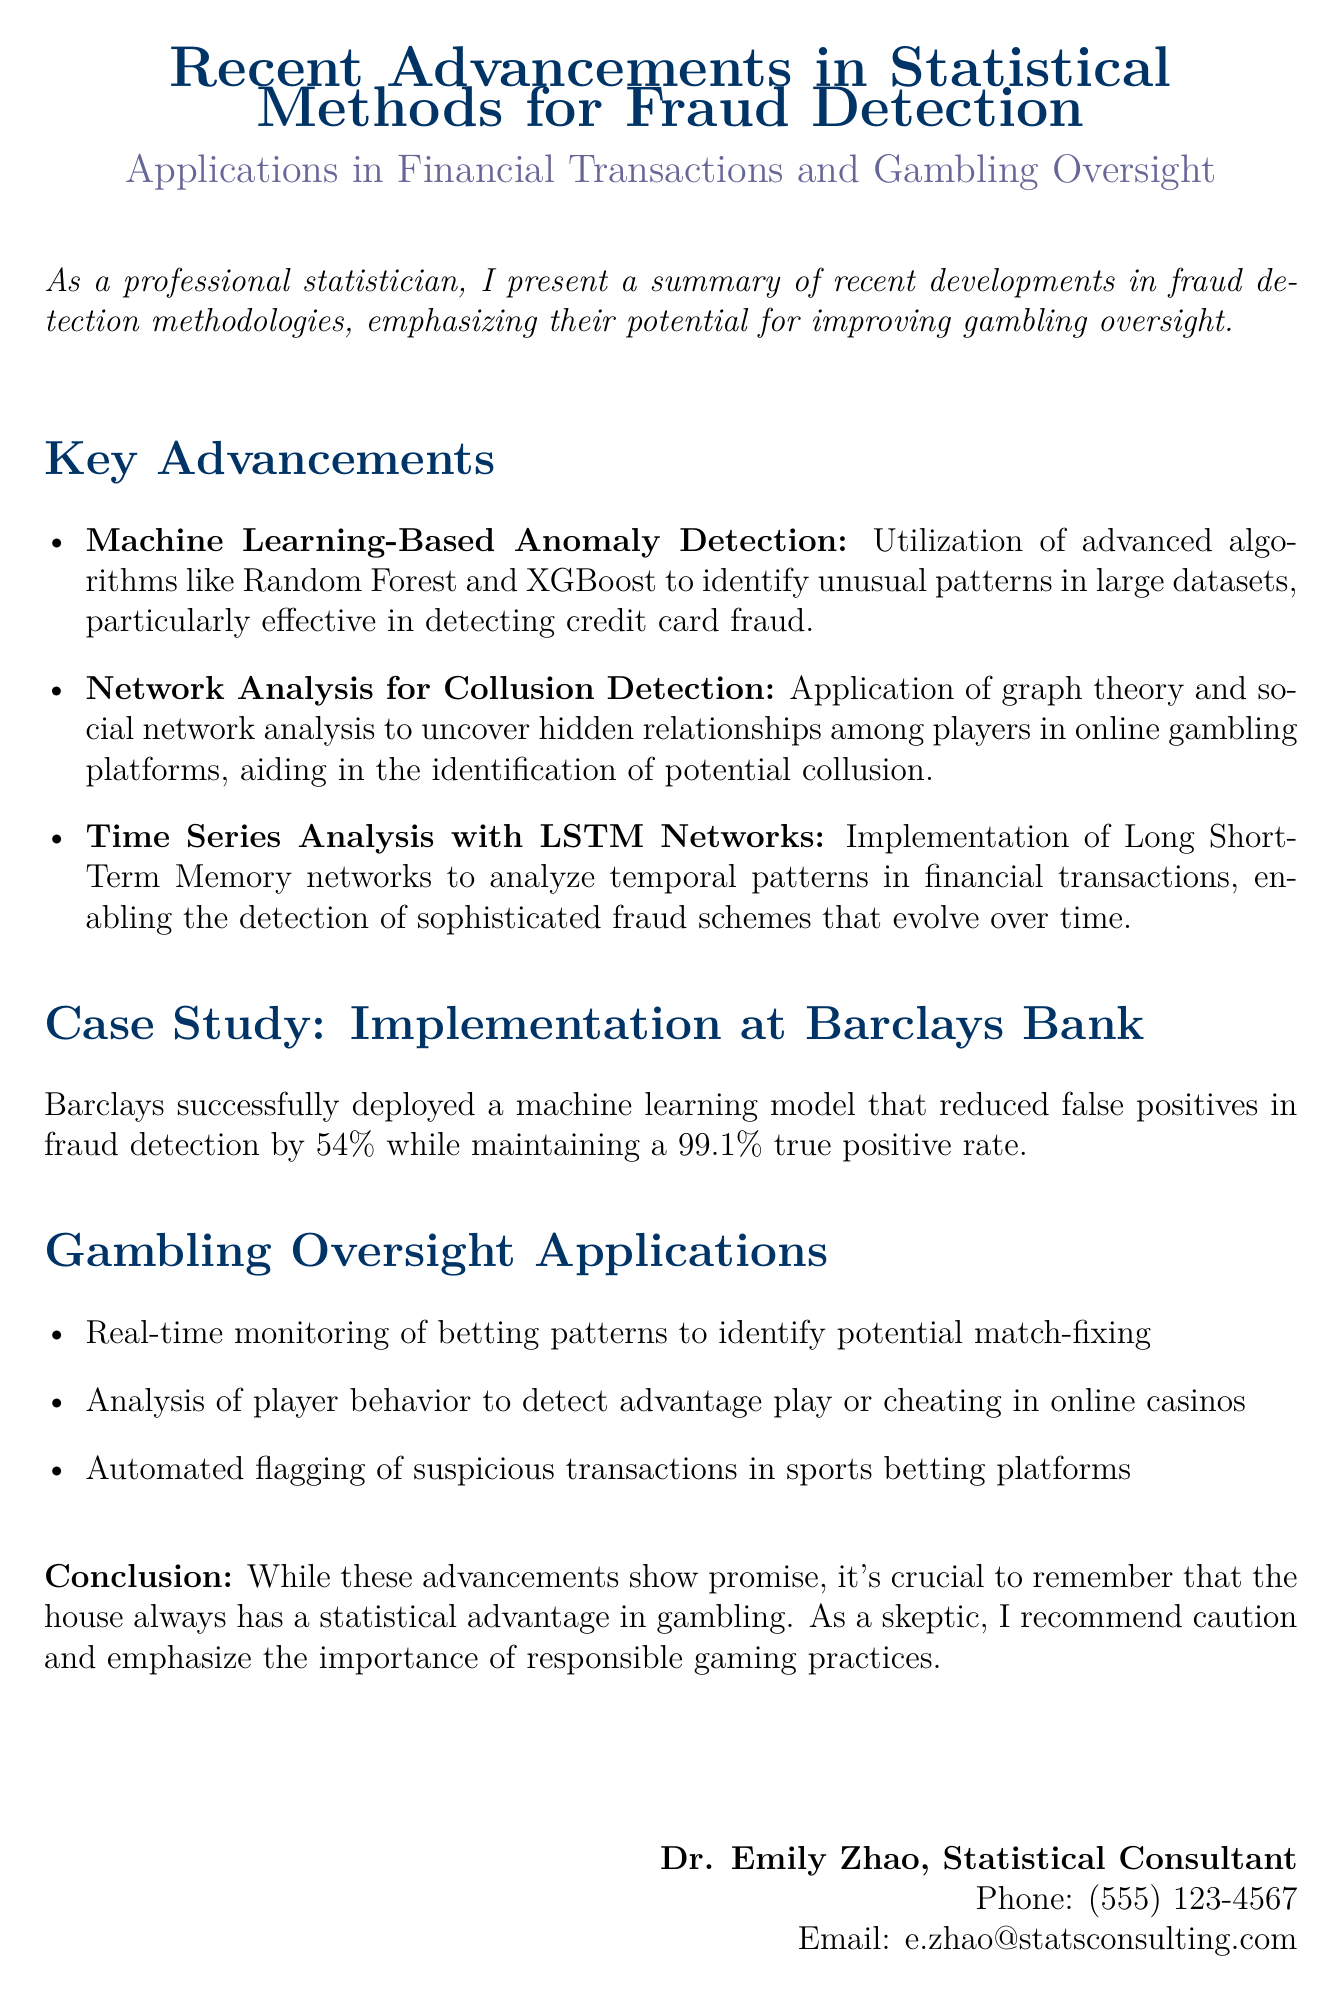What is the title of the document? The title of the document is presented prominently at the top of the rendered fax.
Answer: Recent Advancements in Statistical Methods for Fraud Detection Who is the author of the document? The author's name is provided at the end of the document.
Answer: Dr. Emily Zhao What percentage reduction in false positives was achieved by Barclays Bank? The document states the specific percentage by which false positives were reduced.
Answer: 54% What method is used for collusion detection in online gambling? The document specifies a particular analytical method used to uncover player relationships.
Answer: Network Analysis What is the true positive rate maintained by the machine learning model at Barclays? The document provides the specific rate achieved by the model in fraud detection.
Answer: 99.1% What type of network is mentioned for analyzing temporal patterns? The document describes a specific type of network used for analyzing data over time.
Answer: LSTM Networks What is one of the applications for gambling oversight mentioned? The document lists a specific way the advancements can be applied to monitor gambling activities.
Answer: Real-time monitoring of betting patterns What statistical advantage is highlighted at the conclusion? The conclusion emphasizes a fundamental principle associated with gambling activities.
Answer: House advantage 